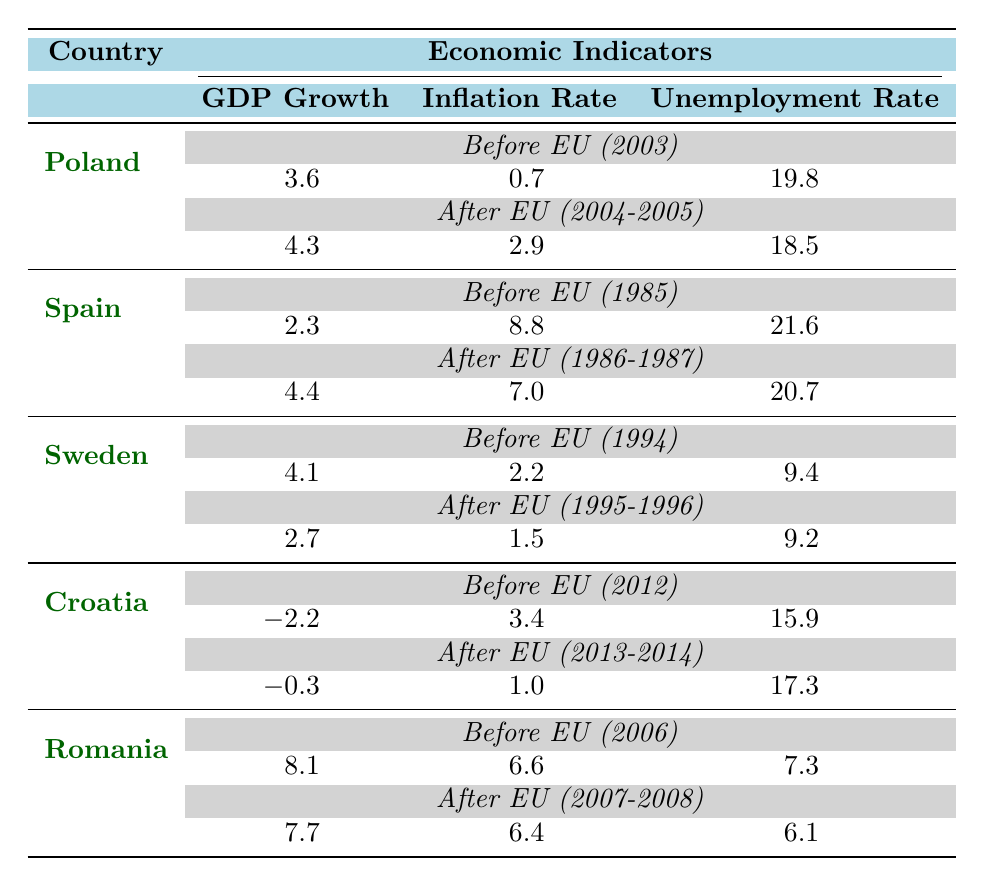What was Poland's GDP Growth in 2003? The table shows Poland's GDP Growth for the year 2003 as 3.6. It is listed under the 'Before EU' section for that country.
Answer: 3.6 What was the average Unemployment Rate in Spain after joining the EU (1986-1987)? The table provides the Unemployment Rates for Spain after joining the EU as 21.2 (1986) and 20.2 (1987). To find the average, sum these values (21.2 + 20.2 = 41.4) and divide by 2, which gives 41.4/2 = 20.7.
Answer: 20.7 Did Sweden's GDP Growth increase or decrease after joining the EU? The table indicates that Sweden's GDP Growth was 4.1 before joining the EU in 1994 and decreased to 2.7 after joining the EU in 1995 and 1996. Therefore, it decreased.
Answer: Decrease What is the difference in Inflation Rate in Romania before and after joining the EU? Romania had an Inflation Rate of 6.6 before joining the EU in 2006 and 6.4 after joining in 2007-2008. The difference is 6.6 - 6.4 = 0.2.
Answer: 0.2 What was the highest GDP Growth recorded for any country before they joined the EU, and which country was it? Referring to the table, Romania had the highest GDP Growth before joining the EU at 8.1 in 2006.
Answer: 8.1, Romania What was Croatia's Unemployment Rate before and after they joined the EU? Croatia's Unemployment Rate was 15.9 before joining the EU in 2012 and 17.3 after joining in 2013-2014. Therefore, it increased after joining.
Answer: 15.9 before, 17.3 after What was the average Inflation Rate for Poland during the years after joining the EU? After joining the EU, Poland had Inflation Rates of 3.6 (2004) and 2.2 (2005). To find the average, sum these values (3.6 + 2.2 = 5.8) and divide by 2, resulting in an average of 5.8/2 = 2.9.
Answer: 2.9 Did Spain's Unemployment Rate improve after they joined the EU? Spain's Unemployment Rate was 21.6 before joining the EU in 1985 and improved to 20.7 after joining in 1986-1987, indicating improvement.
Answer: Yes What is the trend in GDP Growth for Croatia from before joining less to after joining the EU? Before joining the EU, Croatia's GDP Growth was -2.2 in 2012 and slightly improved to -0.3 in 2013 and -0.1 in 2014 after joining, indicating a positive trend despite still being negative.
Answer: Positive trend 